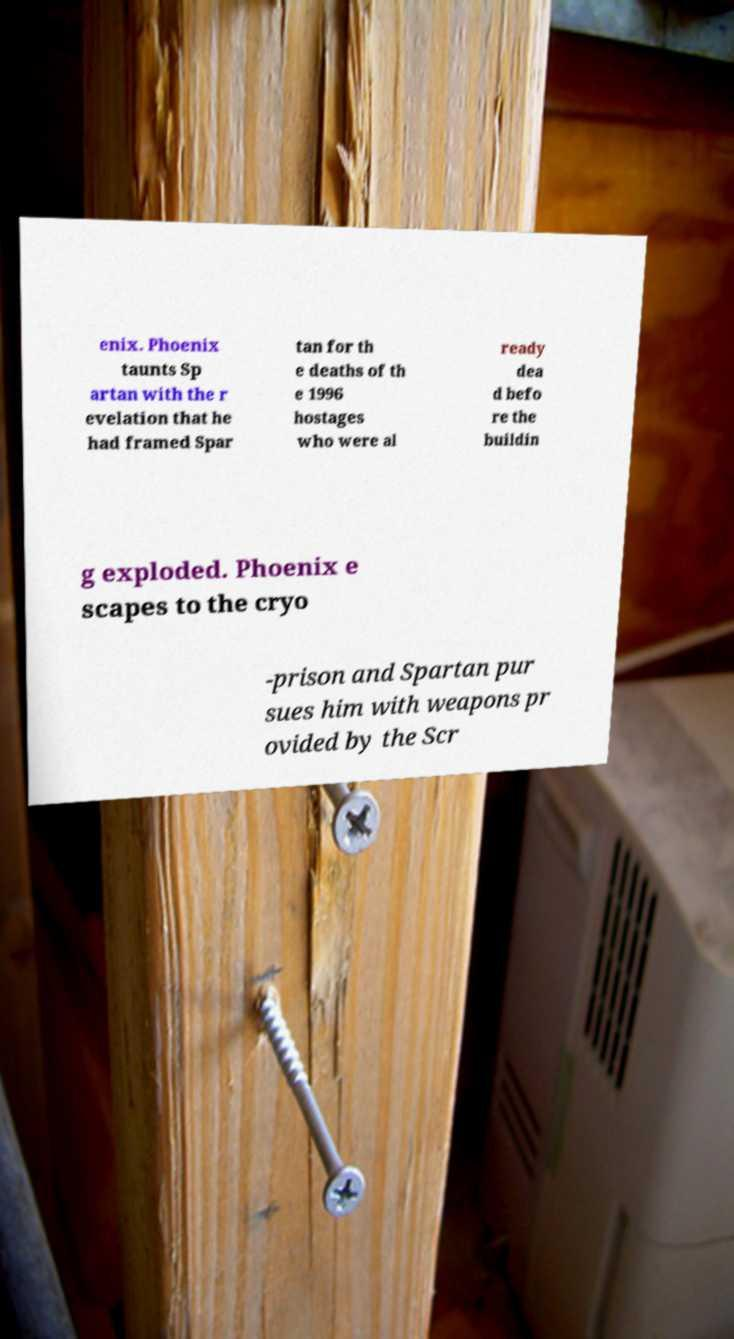For documentation purposes, I need the text within this image transcribed. Could you provide that? enix. Phoenix taunts Sp artan with the r evelation that he had framed Spar tan for th e deaths of th e 1996 hostages who were al ready dea d befo re the buildin g exploded. Phoenix e scapes to the cryo -prison and Spartan pur sues him with weapons pr ovided by the Scr 